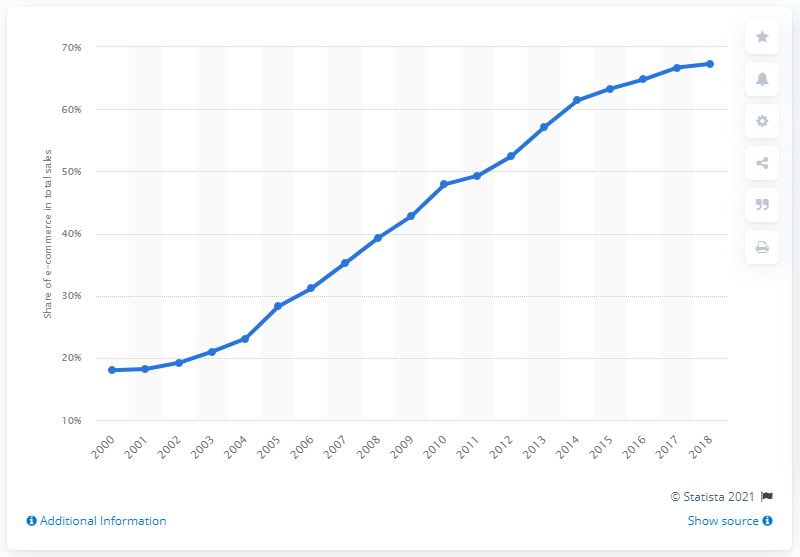Draw attention to some important aspects in this diagram. In 2018, e-commerce sales accounted for 67.3% of total manufacturing shipments. In the previous years, e-commerce sales accounted for approximately 67.3% of total manufacturing shipments. In 2018, the B2B e-commerce sector generated $67.3 billion worth of manufacturing shipments, exceeding the previous year's total by a significant margin. 